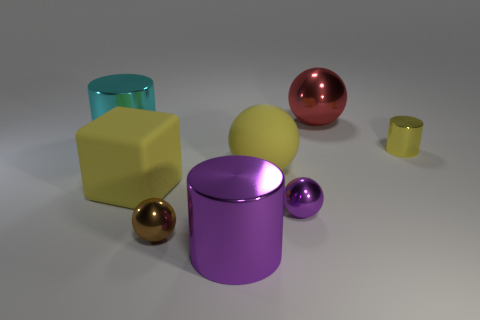Subtract all rubber spheres. How many spheres are left? 3 Add 1 cyan cylinders. How many objects exist? 9 Subtract 2 cylinders. How many cylinders are left? 1 Add 3 small cylinders. How many small cylinders are left? 4 Add 1 small metallic cylinders. How many small metallic cylinders exist? 2 Subtract all brown balls. How many balls are left? 3 Subtract 1 brown spheres. How many objects are left? 7 Subtract all blocks. How many objects are left? 7 Subtract all blue blocks. Subtract all blue balls. How many blocks are left? 1 Subtract all yellow spheres. How many cyan cylinders are left? 1 